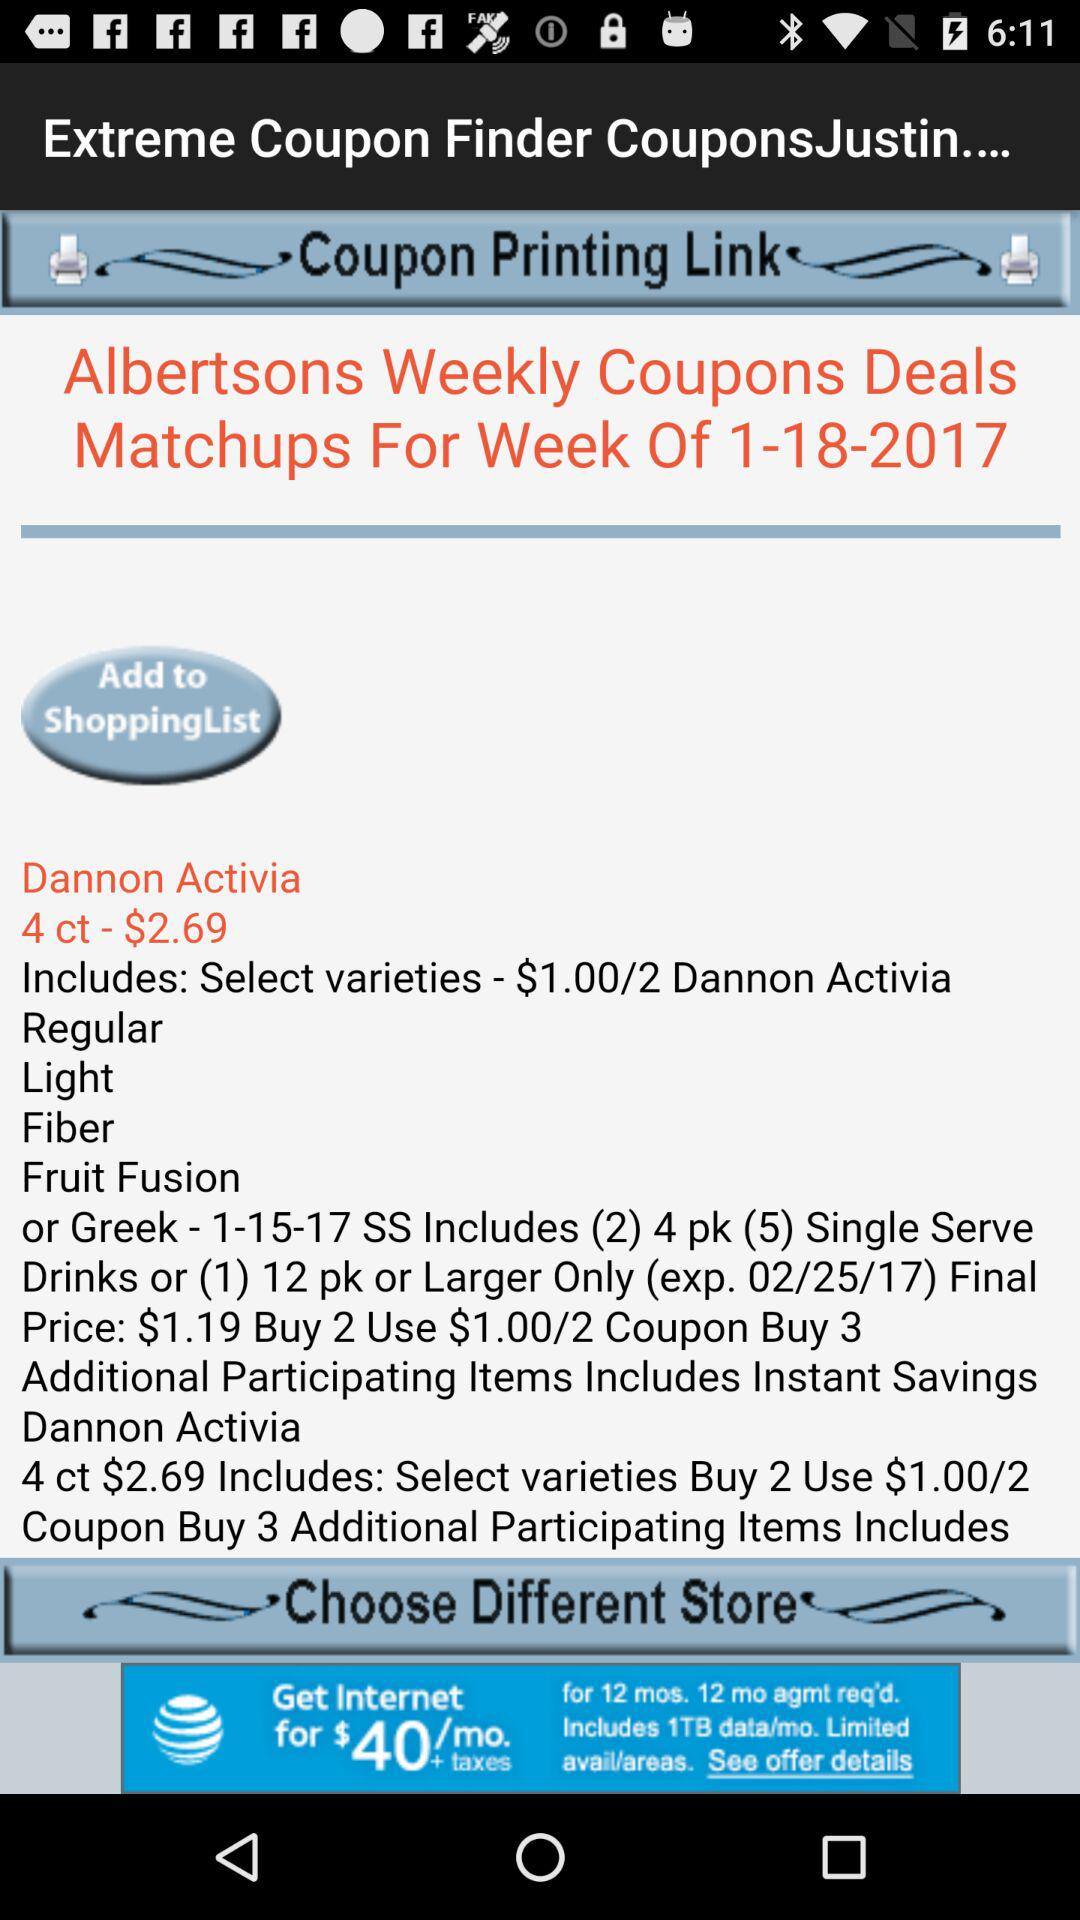What are the varieties included in "Greek - 1-15-17 SS"?
Answer the question using a single word or phrase. The varieties are "(2) 4 pk (5) Single Serve Drinks or (1) 12 pk or Larger Only (exp. 02/25/17)" 